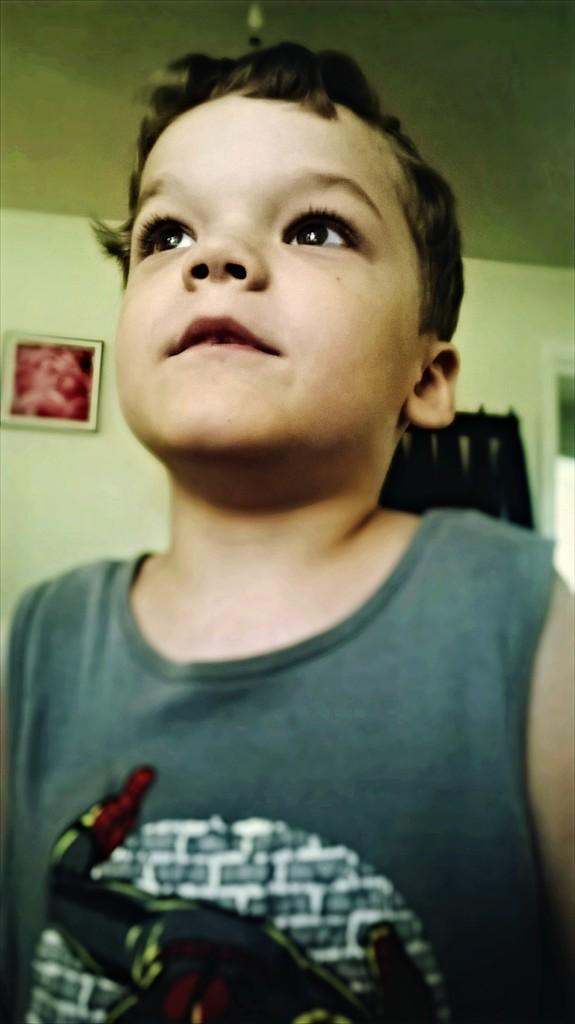Who is the main subject in the image? There is a boy in the center of the image. What can be seen on the wall in the background? There is a frame on the wall in the background. How would you describe the wall in the image? The wall is plain. What is visible at the top of the image? There is a ceiling visible at the top of the image. Can you see any mountains in the image? No, there are no mountains present in the image. Are there any bats hanging from the ceiling in the image? No, there are no bats present in the image. 